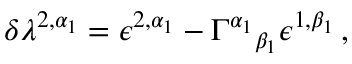<formula> <loc_0><loc_0><loc_500><loc_500>\delta \lambda ^ { 2 , \alpha _ { 1 } } = \epsilon ^ { 2 , \alpha _ { 1 } } - \Gamma ^ { \alpha _ { 1 } _ { \beta _ { 1 } } \epsilon ^ { 1 , \beta _ { 1 } } \, ,</formula> 